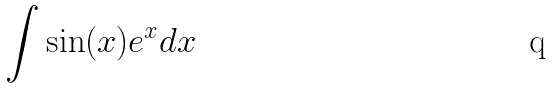Convert formula to latex. <formula><loc_0><loc_0><loc_500><loc_500>\int \sin ( x ) e ^ { x } d x</formula> 